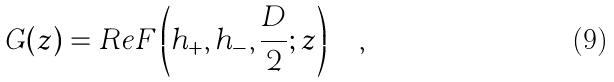Convert formula to latex. <formula><loc_0><loc_0><loc_500><loc_500>G ( z ) = R e F \left ( h _ { + } , h _ { - } , \frac { D } { 2 } ; z \right ) \quad ,</formula> 